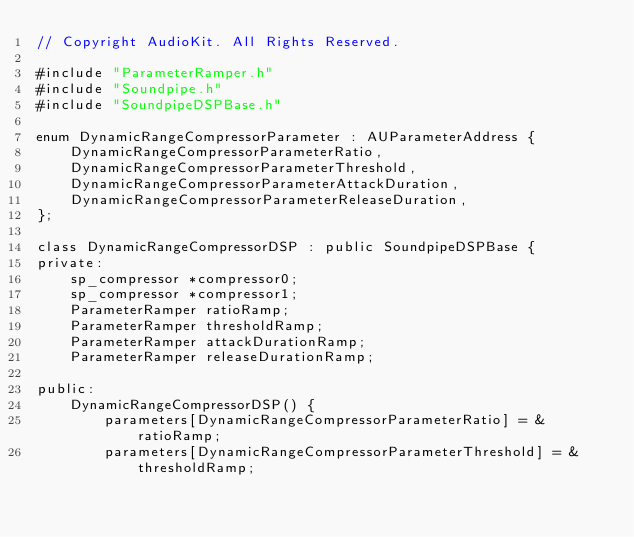Convert code to text. <code><loc_0><loc_0><loc_500><loc_500><_ObjectiveC_>// Copyright AudioKit. All Rights Reserved.

#include "ParameterRamper.h"
#include "Soundpipe.h"
#include "SoundpipeDSPBase.h"

enum DynamicRangeCompressorParameter : AUParameterAddress {
    DynamicRangeCompressorParameterRatio,
    DynamicRangeCompressorParameterThreshold,
    DynamicRangeCompressorParameterAttackDuration,
    DynamicRangeCompressorParameterReleaseDuration,
};

class DynamicRangeCompressorDSP : public SoundpipeDSPBase {
private:
    sp_compressor *compressor0;
    sp_compressor *compressor1;
    ParameterRamper ratioRamp;
    ParameterRamper thresholdRamp;
    ParameterRamper attackDurationRamp;
    ParameterRamper releaseDurationRamp;

public:
    DynamicRangeCompressorDSP() {
        parameters[DynamicRangeCompressorParameterRatio] = &ratioRamp;
        parameters[DynamicRangeCompressorParameterThreshold] = &thresholdRamp;</code> 